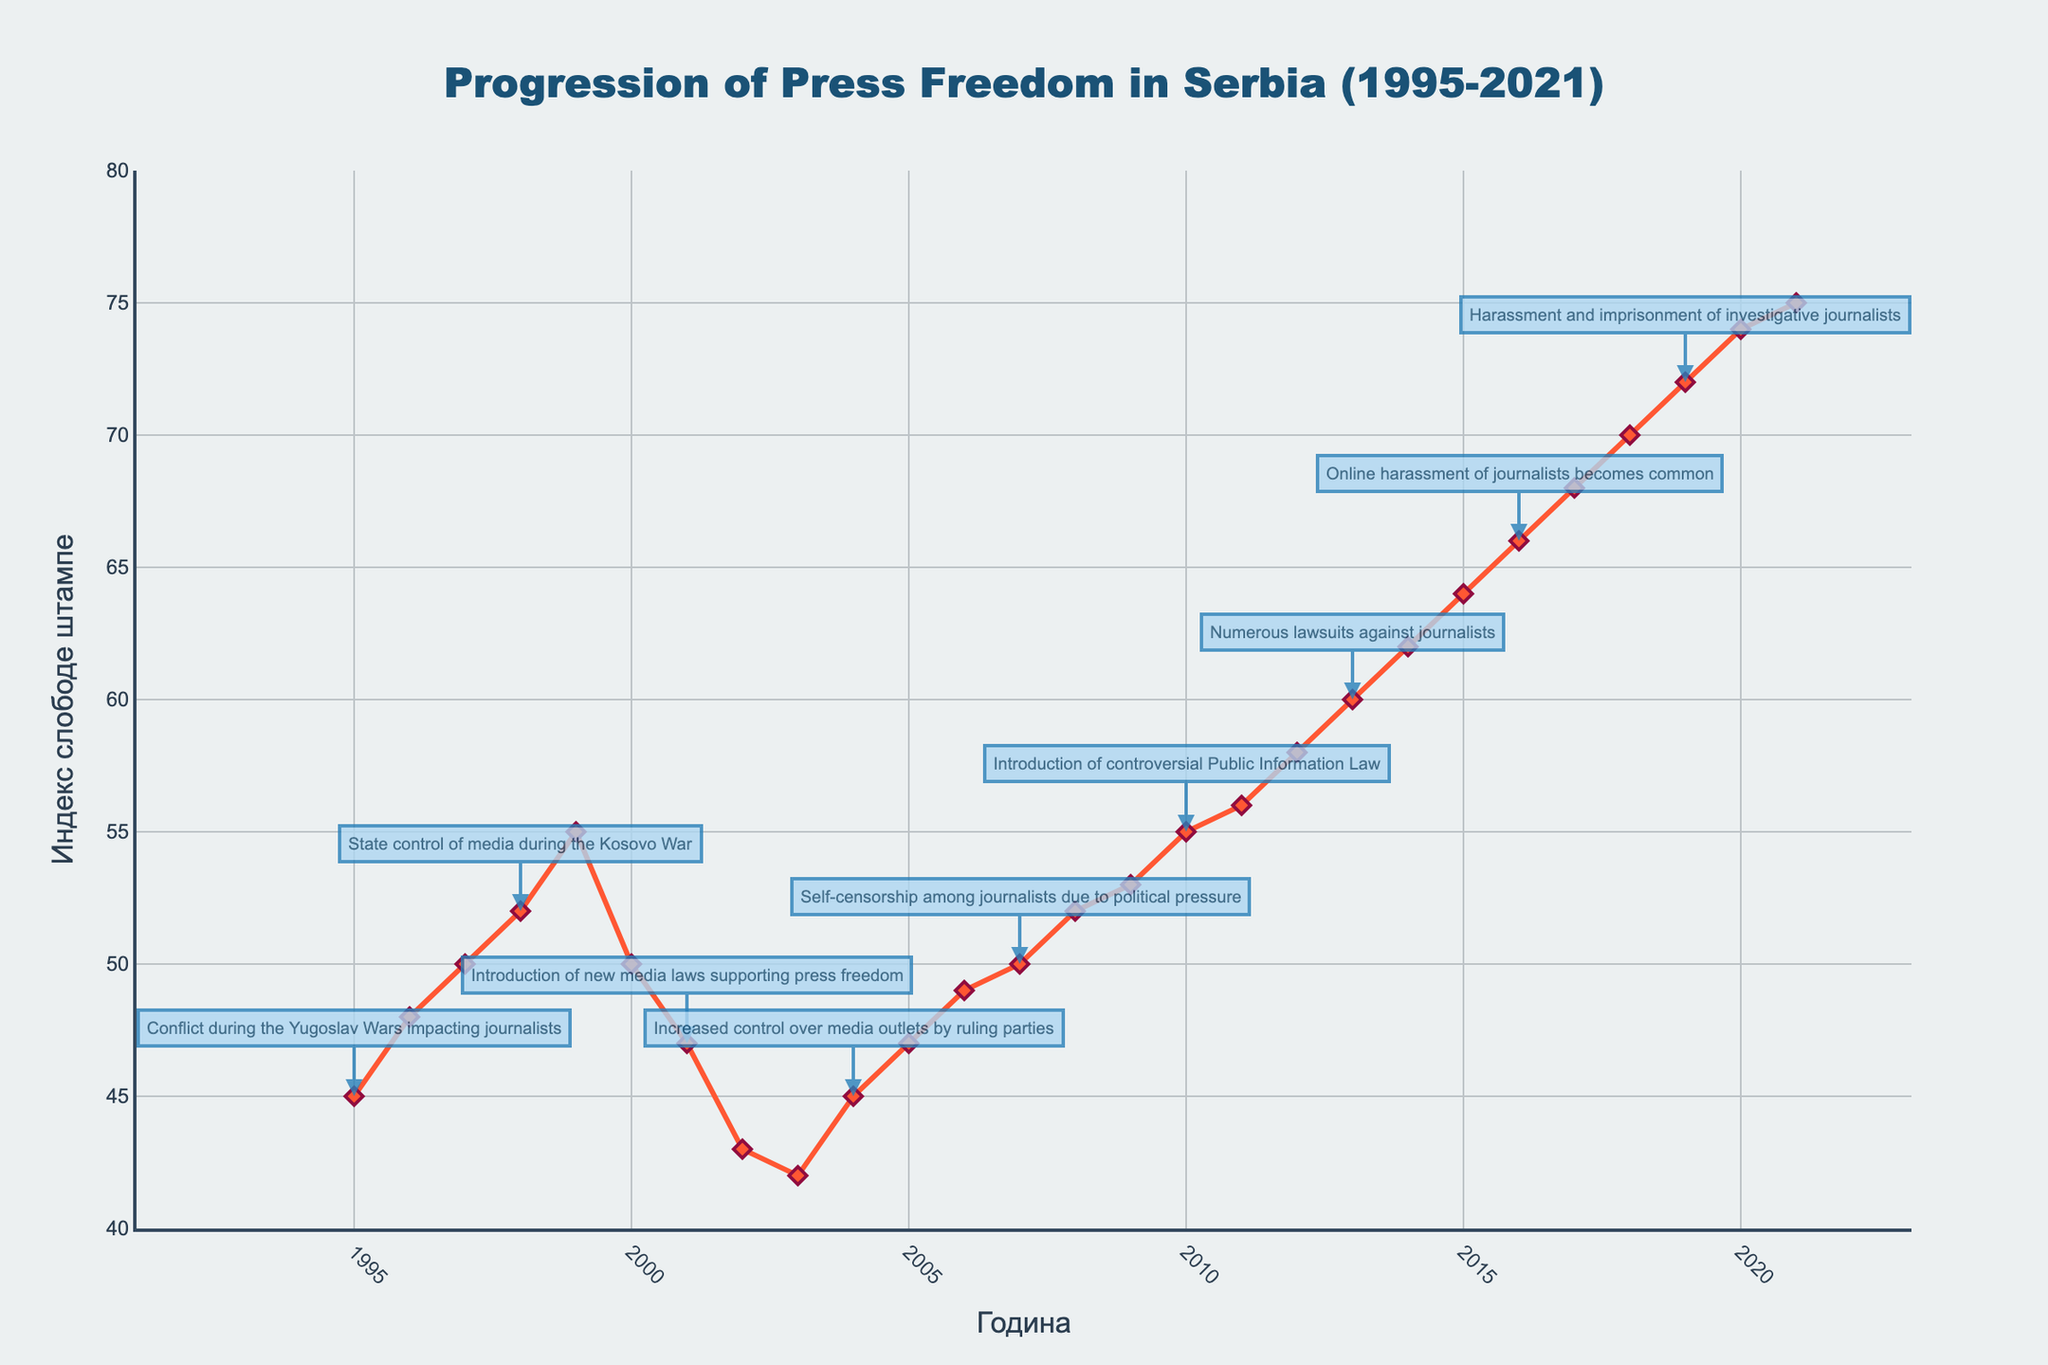What is the title of the plot? The title of a plot is usually found at the top center of the figure. In this case, the given title is 'Progression of Press Freedom in Serbia (1995-2021)'.
Answer: 'Progression of Press Freedom in Serbia (1995-2021)' What is the horizontal axis labeled as? The label for the horizontal axis is usually found directly below the axis. In this plot, it is labeled as 'Година' which means 'Year' in Serbian.
Answer: 'Година' What is the value of the Press Freedom Score in 2000? Locate the year 2000 on the horizontal axis and then find the corresponding data point on the plot. The value associated with this point is 50.
Answer: 50 Between which years did the Press Freedom Score first increase to 55? Examine the trend of the Press Freedom Score over the years. The first occurrence of 55 happens between the years 1998 and 1999.
Answer: 1998 and 1999 What is the range of the y-axis? The range of the y-axis can be observed from the minimum and maximum values shown along the axis. In this plot, it ranges from 40 to 80.
Answer: 40 to 80 During which year did the Prime Minister's assassination impact the press climate? Identify the year associated with the incident specified. The assassination of Prime Minister Zoran Đinđić impacting the press climate happened in 2003 according to the dataset.
Answer: 2003 By how many points did the Press Freedom Score increase between 2010 and 2011? Note the scores for the years 2010 and 2011, which are 55 and 56 respectively, and calculate the difference: 56 - 55 = 1.
Answer: 1 Which year had the highest Press Freedom Score and what was the score? Scan through the plot to find the peak point which occurs in 2021 with the score being 75.
Answer: 2021 and 75 Which event marked the sharpest decline in press freedom scores after a temporary increase? Look for the year where the score increases and then sharply declines. After the temporary increase in 2000, there is a decrease in 2001 from 50 to 47. The incident is listed as the introduction of new media laws supporting press freedom.
Answer: Introduction of new media laws supporting press freedom in 2001 What is the overall trend in Press Freedom Scores from 1995 to 2021? To identify the overall trend, observe the general direction of the data points over the entire time span, from 1995 (score 45) to 2021 (score 75). The overall trend shows an increase in Press Freedom Scores over the years.
Answer: Increasing trend 